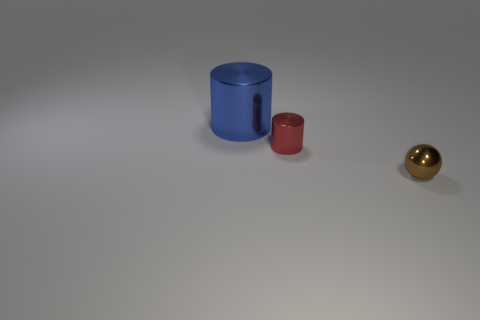Add 3 cyan rubber spheres. How many objects exist? 6 Subtract all spheres. How many objects are left? 2 Add 3 small objects. How many small objects exist? 5 Subtract 0 blue balls. How many objects are left? 3 Subtract 2 cylinders. How many cylinders are left? 0 Subtract all red cylinders. Subtract all gray blocks. How many cylinders are left? 1 Subtract all brown cylinders. How many red balls are left? 0 Subtract all big yellow balls. Subtract all tiny red shiny things. How many objects are left? 2 Add 2 blue shiny cylinders. How many blue shiny cylinders are left? 3 